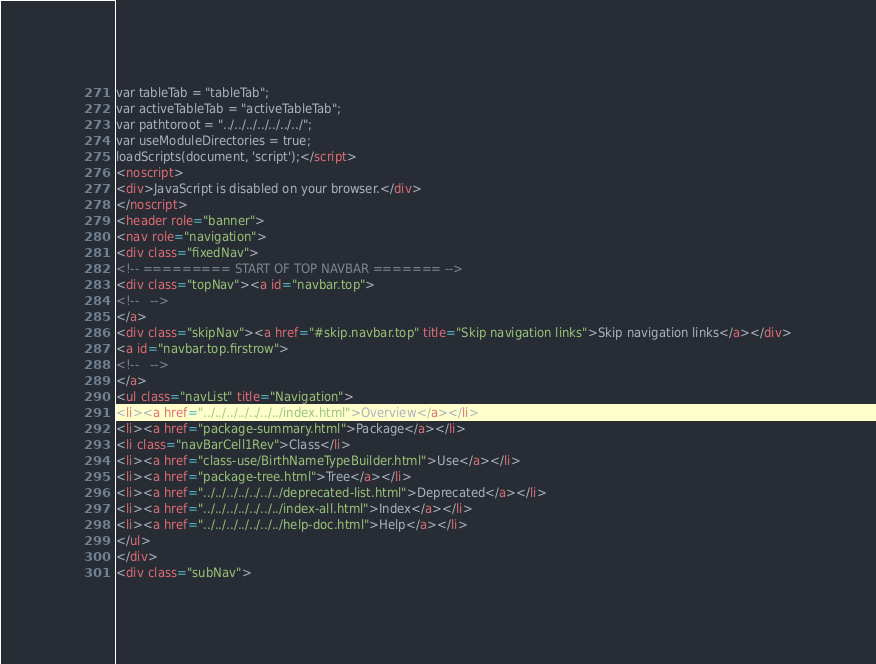Convert code to text. <code><loc_0><loc_0><loc_500><loc_500><_HTML_>var tableTab = "tableTab";
var activeTableTab = "activeTableTab";
var pathtoroot = "../../../../../../../";
var useModuleDirectories = true;
loadScripts(document, 'script');</script>
<noscript>
<div>JavaScript is disabled on your browser.</div>
</noscript>
<header role="banner">
<nav role="navigation">
<div class="fixedNav">
<!-- ========= START OF TOP NAVBAR ======= -->
<div class="topNav"><a id="navbar.top">
<!--   -->
</a>
<div class="skipNav"><a href="#skip.navbar.top" title="Skip navigation links">Skip navigation links</a></div>
<a id="navbar.top.firstrow">
<!--   -->
</a>
<ul class="navList" title="Navigation">
<li><a href="../../../../../../../index.html">Overview</a></li>
<li><a href="package-summary.html">Package</a></li>
<li class="navBarCell1Rev">Class</li>
<li><a href="class-use/BirthNameTypeBuilder.html">Use</a></li>
<li><a href="package-tree.html">Tree</a></li>
<li><a href="../../../../../../../deprecated-list.html">Deprecated</a></li>
<li><a href="../../../../../../../index-all.html">Index</a></li>
<li><a href="../../../../../../../help-doc.html">Help</a></li>
</ul>
</div>
<div class="subNav"></code> 